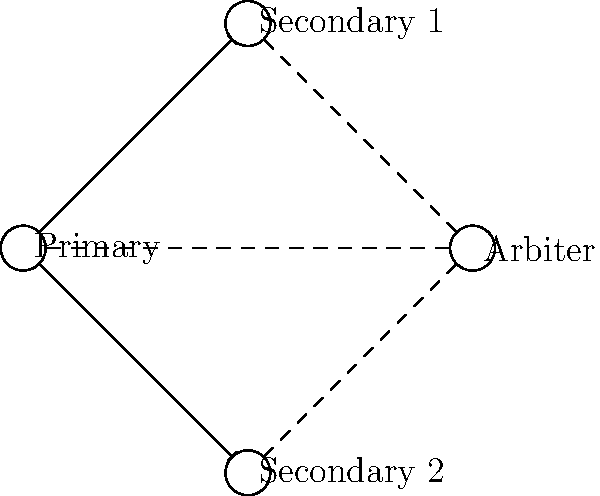Analyze the database replication topology depicted in the network diagram. Which type of MongoDB replication configuration does this represent, and what potential issue might arise if the Primary node fails? To answer this question, let's analyze the diagram step-by-step:

1. Node identification:
   - We see four nodes: Primary, Secondary 1, Secondary 2, and Arbiter.
   - The Primary node is connected to both Secondary nodes with solid arrows.
   - All nodes are connected to the Arbiter with dashed lines.

2. Topology analysis:
   - This configuration shows a Primary node replicating data to two Secondary nodes.
   - The presence of an Arbiter node indicates this is not a simple Primary-Secondary setup.

3. MongoDB replication configuration:
   - This topology represents a MongoDB Replica Set with an Arbiter.
   - Replica Sets in MongoDB provide high availability and automatic failover.

4. Role of the Arbiter:
   - The Arbiter doesn't hold data but participates in elections for a new Primary.
   - It helps maintain an odd number of voting members in the replica set.

5. Potential issue if Primary fails:
   - In a typical replica set, if the Primary fails, an election occurs to choose a new Primary.
   - However, with only two data-bearing nodes (Secondary 1 and Secondary 2) and one Arbiter, there's a risk of split-brain scenario.
   - If network partition occurs, isolating one Secondary from the other Secondary and Arbiter, no new Primary can be elected due to lack of majority.

6. Conclusion:
   - This is a MongoDB Replica Set with an Arbiter.
   - The main risk is the potential for split-brain scenario or inability to elect a new Primary if the original Primary fails under certain network conditions.
Answer: MongoDB Replica Set with Arbiter; risk of split-brain scenario or election failure 